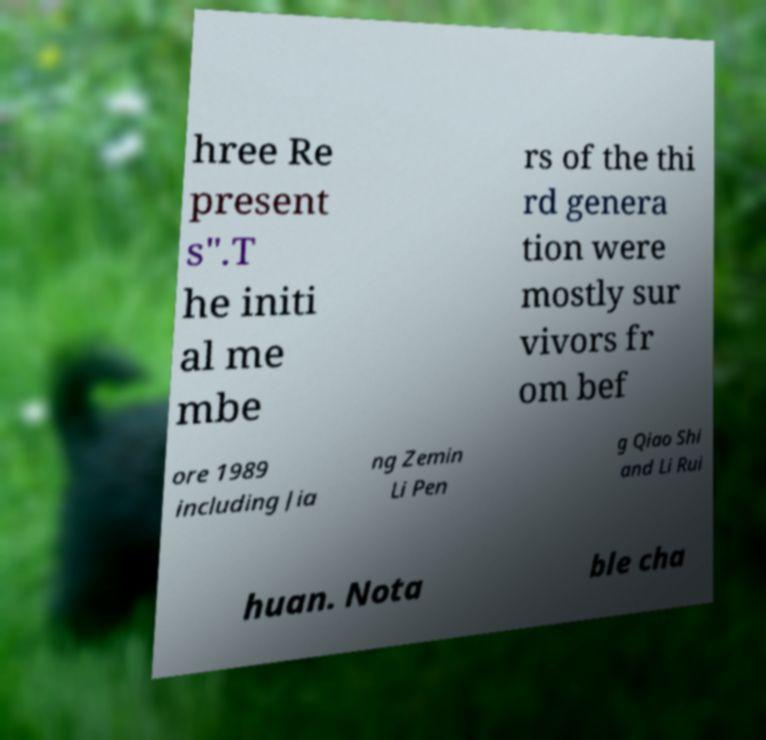Please read and relay the text visible in this image. What does it say? hree Re present s".T he initi al me mbe rs of the thi rd genera tion were mostly sur vivors fr om bef ore 1989 including Jia ng Zemin Li Pen g Qiao Shi and Li Rui huan. Nota ble cha 